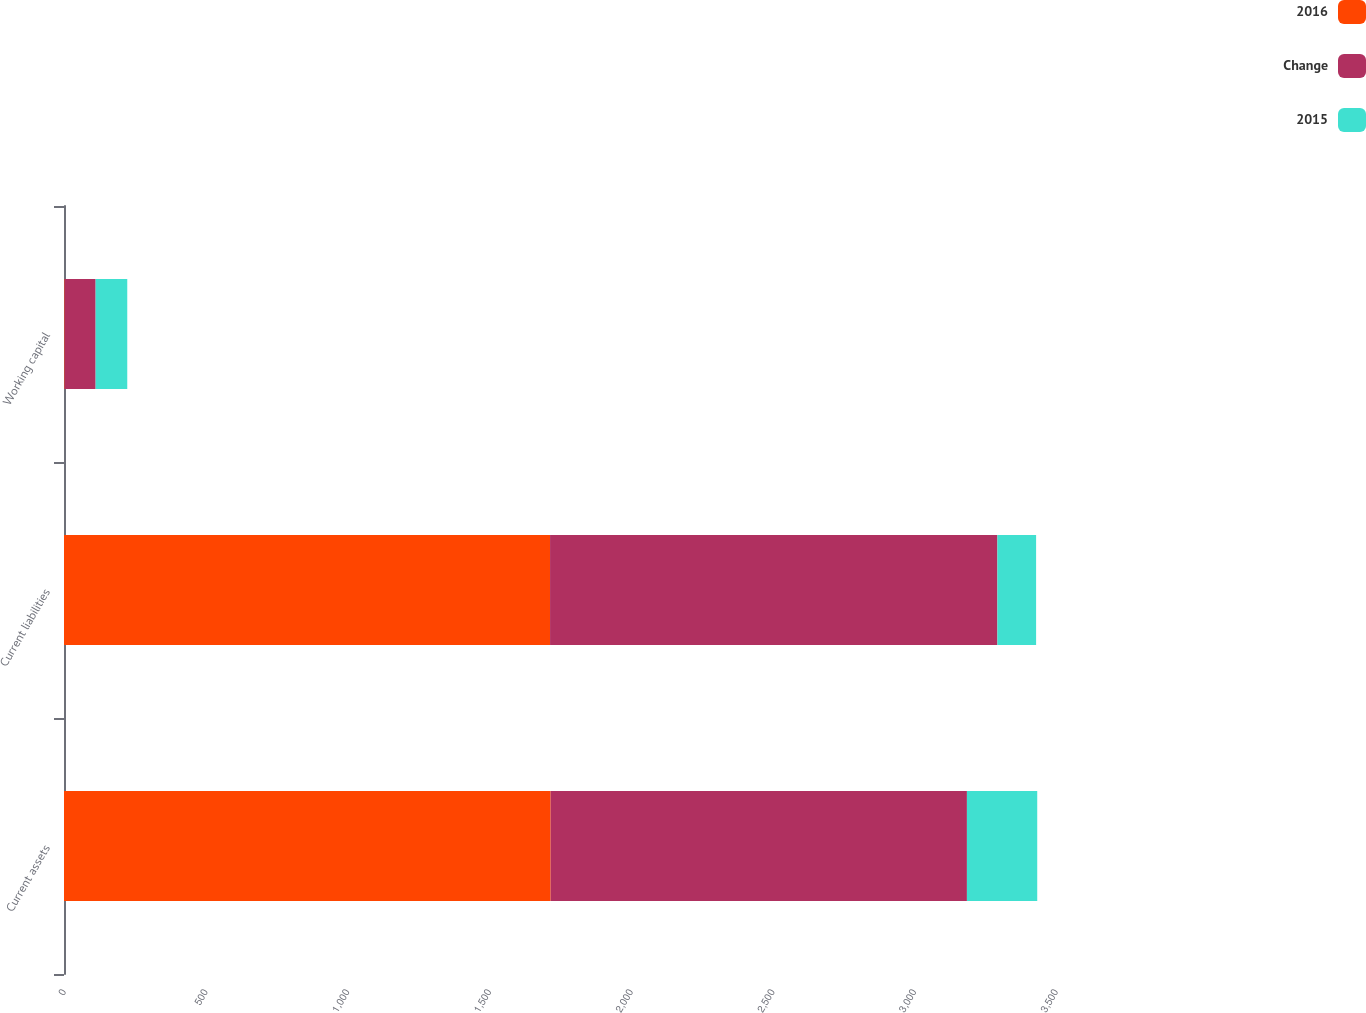Convert chart to OTSL. <chart><loc_0><loc_0><loc_500><loc_500><stacked_bar_chart><ecel><fcel>Current assets<fcel>Current liabilities<fcel>Working capital<nl><fcel>2016<fcel>1716.9<fcel>1714.9<fcel>2<nl><fcel>Change<fcel>1468.8<fcel>1578.4<fcel>109.6<nl><fcel>2015<fcel>248.1<fcel>136.5<fcel>111.6<nl></chart> 